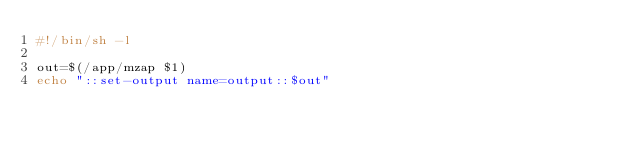Convert code to text. <code><loc_0><loc_0><loc_500><loc_500><_Bash_>#!/bin/sh -l

out=$(/app/mzap $1)
echo "::set-output name=output::$out"</code> 